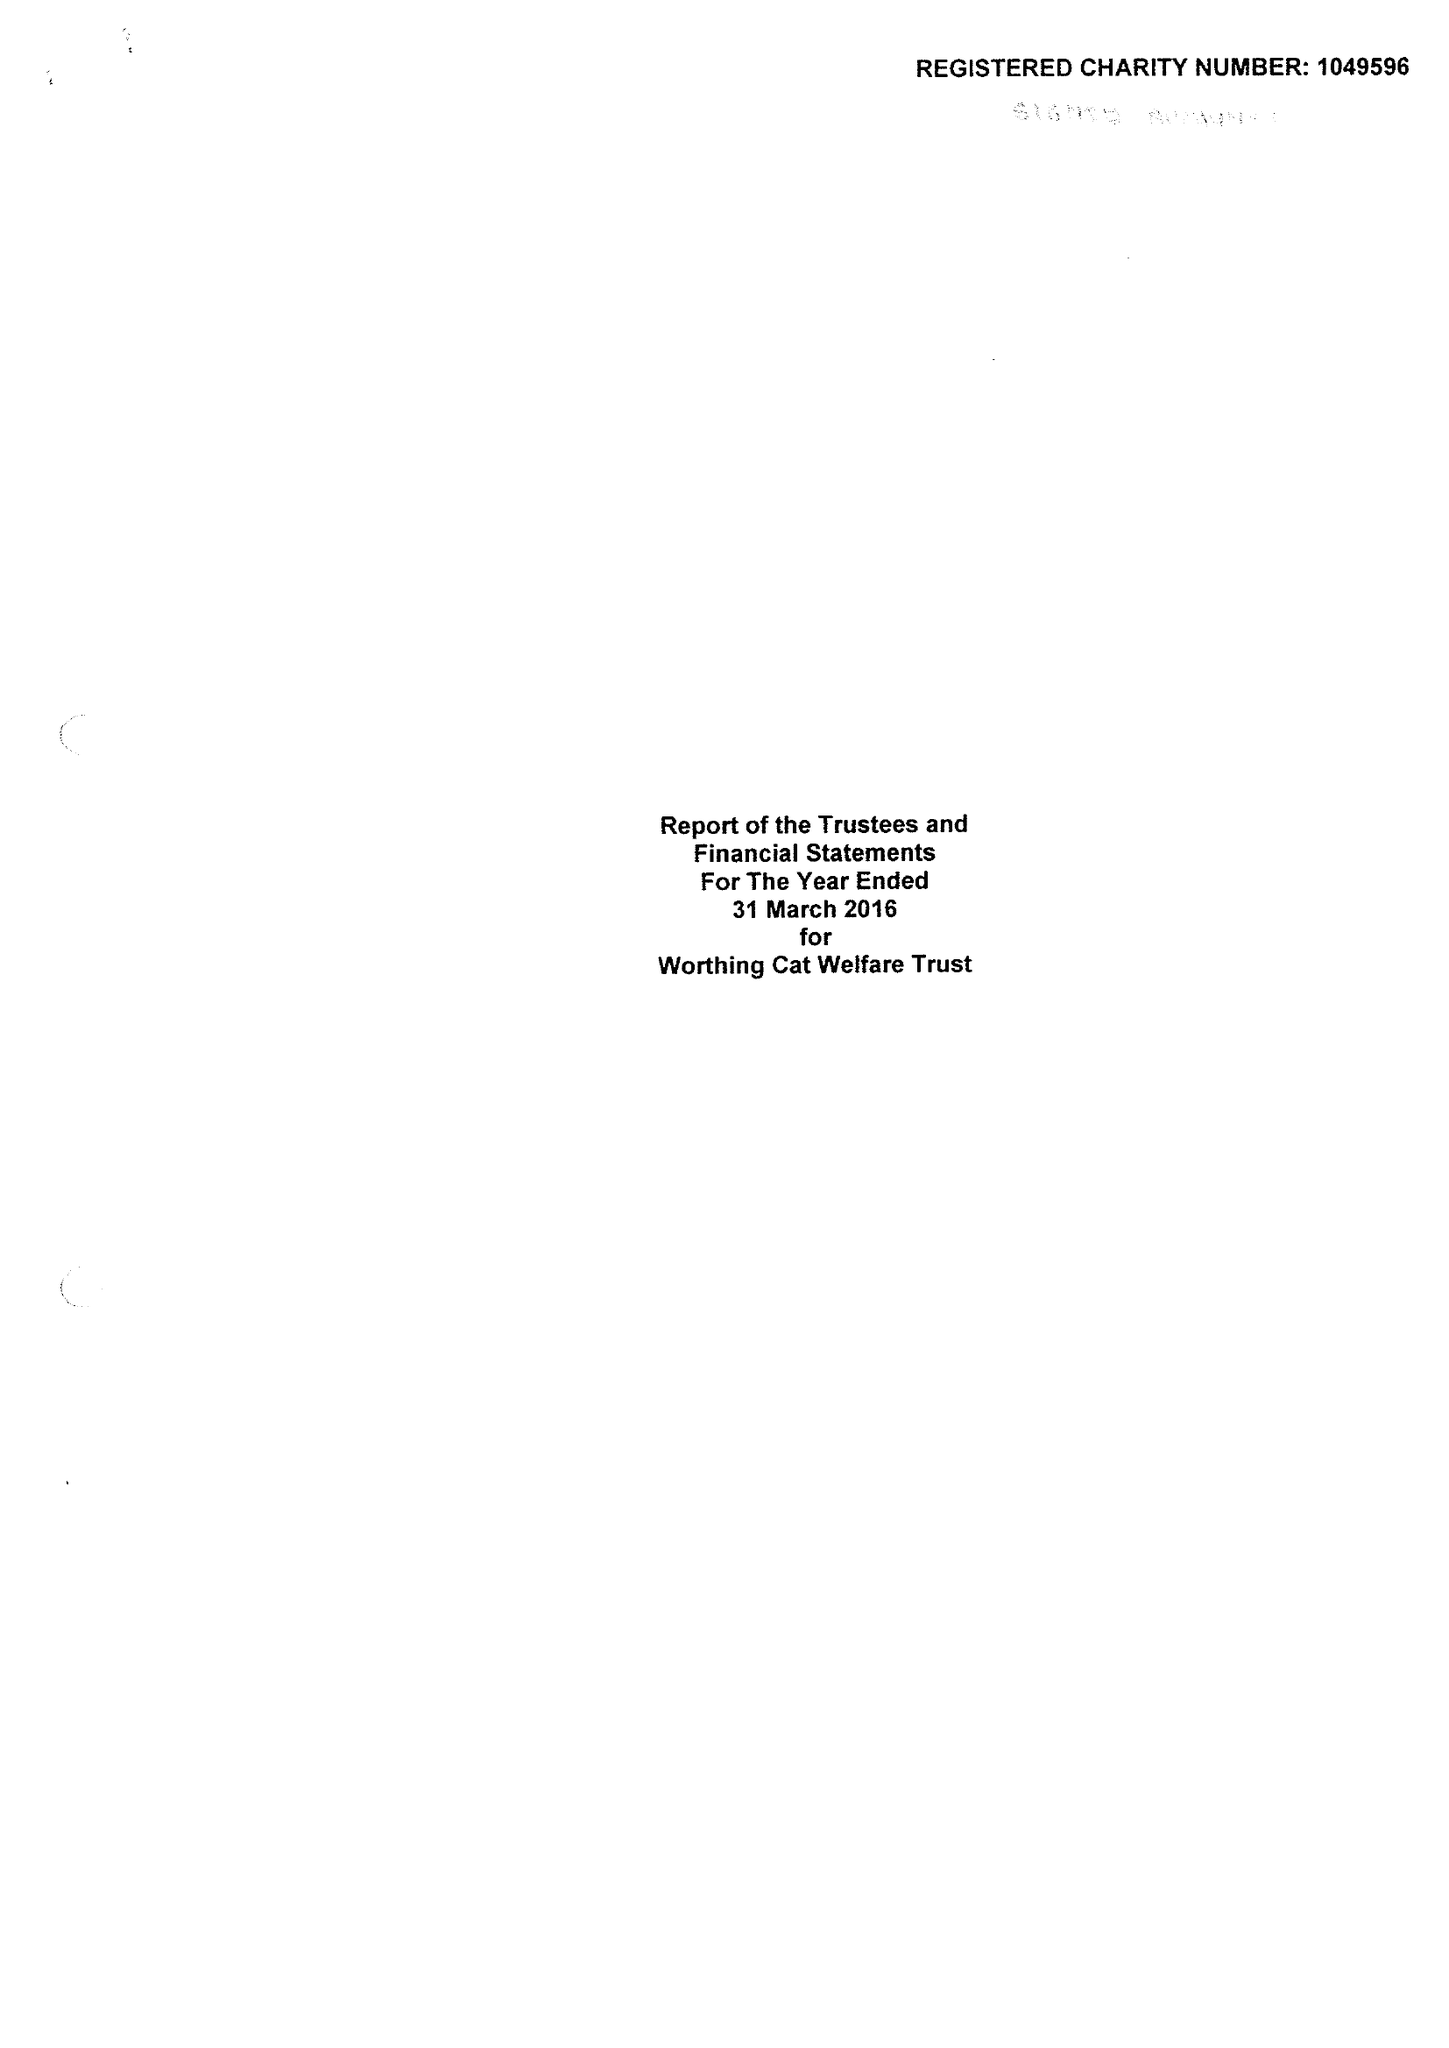What is the value for the address__postcode?
Answer the question using a single word or phrase. BN14 0EY 